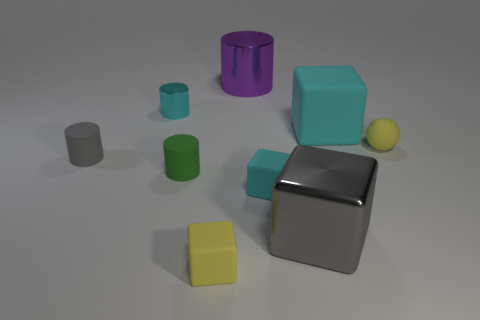Subtract all balls. How many objects are left? 8 Add 1 tiny yellow rubber balls. How many tiny yellow rubber balls exist? 2 Subtract 0 brown spheres. How many objects are left? 9 Subtract all small gray cylinders. Subtract all small cyan cubes. How many objects are left? 7 Add 5 metal cylinders. How many metal cylinders are left? 7 